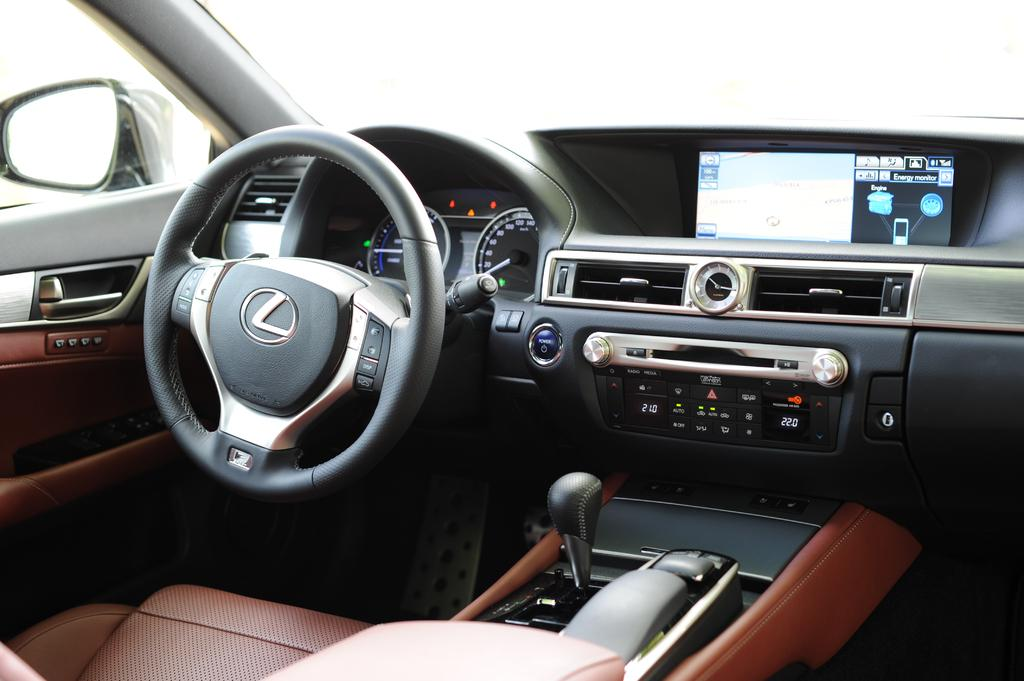What type of vehicle is shown in the image? The image is an inside view of a car. What is the main control device in the car? There is a steering wheel in the image. What other features can be seen in the car? There are buttons, a screen, a handle, a seat, and a mirror visible in the image. How many hens are sitting on the seat in the image? There are no hens present in the image; it is an inside view of a car with no animals visible. What type of mice can be seen interacting with the buttons in the image? There are no mice present in the image; it is an inside view of a car with no animals visible. 